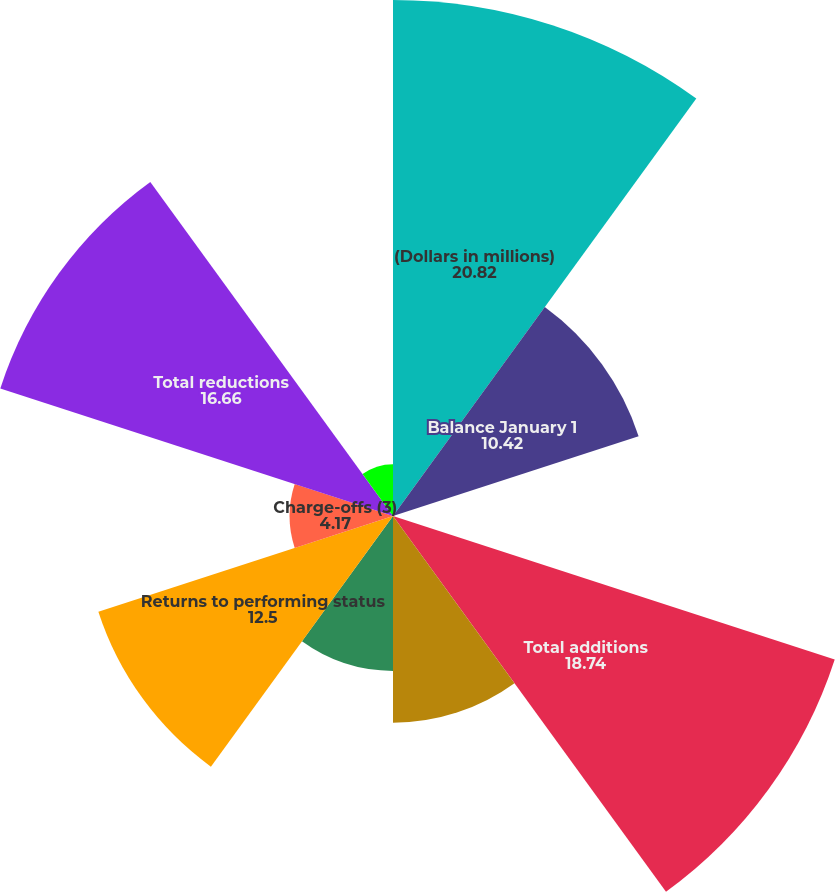Convert chart. <chart><loc_0><loc_0><loc_500><loc_500><pie_chart><fcel>(Dollars in millions)<fcel>Balance January 1<fcel>Transfers from assets<fcel>Total additions<fcel>Paydowns and payoffs<fcel>Sales<fcel>Returns to performing status<fcel>Charge-offs (3)<fcel>Total reductions<fcel>Total net additions to<nl><fcel>20.82%<fcel>10.42%<fcel>0.01%<fcel>18.74%<fcel>8.34%<fcel>6.25%<fcel>12.5%<fcel>4.17%<fcel>16.66%<fcel>2.09%<nl></chart> 